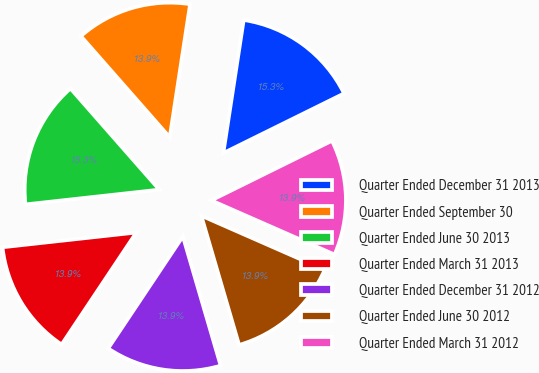Convert chart. <chart><loc_0><loc_0><loc_500><loc_500><pie_chart><fcel>Quarter Ended December 31 2013<fcel>Quarter Ended September 30<fcel>Quarter Ended June 30 2013<fcel>Quarter Ended March 31 2013<fcel>Quarter Ended December 31 2012<fcel>Quarter Ended June 30 2012<fcel>Quarter Ended March 31 2012<nl><fcel>15.28%<fcel>13.89%<fcel>15.28%<fcel>13.89%<fcel>13.89%<fcel>13.89%<fcel>13.89%<nl></chart> 